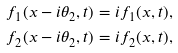Convert formula to latex. <formula><loc_0><loc_0><loc_500><loc_500>f _ { 1 } ( x - i \theta _ { 2 } , t ) & = i f _ { 1 } ( x , t ) , \\ f _ { 2 } ( x - i \theta _ { 2 } , t ) & = i f _ { 2 } ( x , t ) ,</formula> 